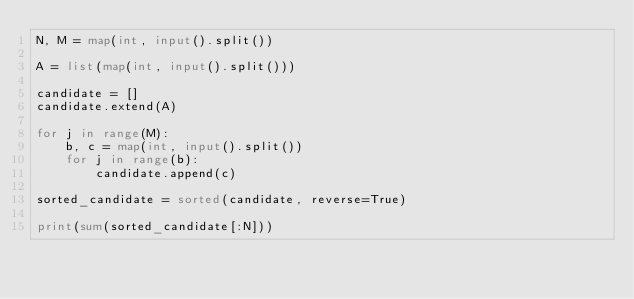<code> <loc_0><loc_0><loc_500><loc_500><_Python_>N, M = map(int, input().split())

A = list(map(int, input().split()))

candidate = []
candidate.extend(A)

for j in range(M):
    b, c = map(int, input().split())
    for j in range(b):
        candidate.append(c)
        
sorted_candidate = sorted(candidate, reverse=True)

print(sum(sorted_candidate[:N]))</code> 